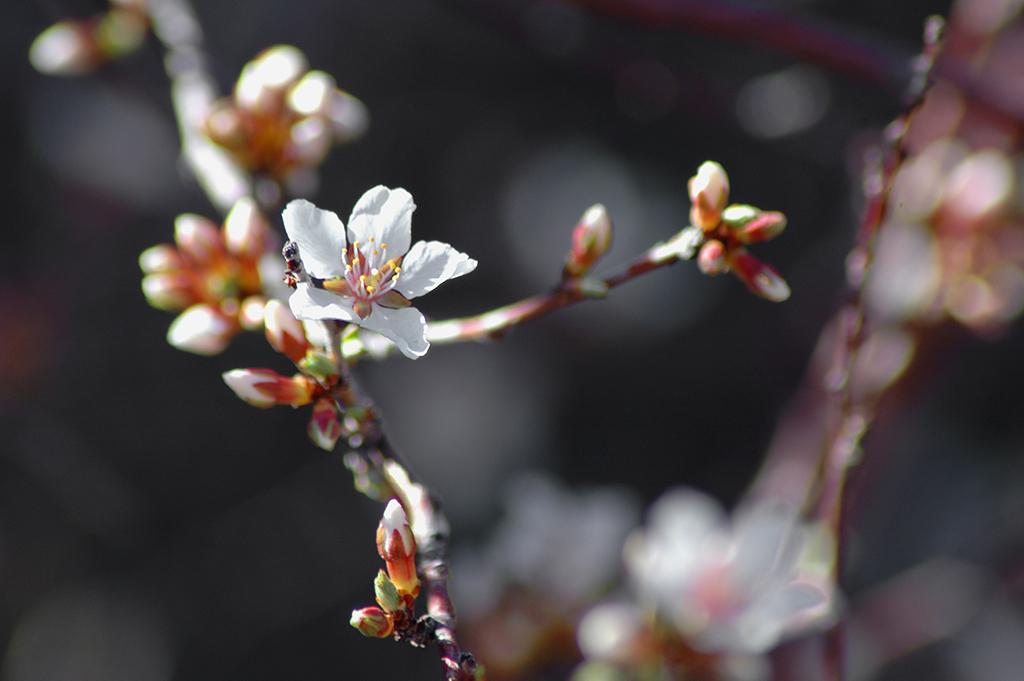What is present in the image? There are flowers in the image. Can you describe the background of the image? The background of the image is blurry. How many cracks can be seen on the plant in the image? There is no plant present in the image, only flowers. What type of line is visible in the image? There is no line visible in the image; only flowers and a blurry background are present. 